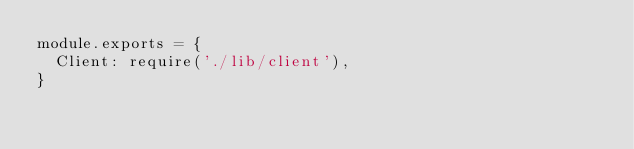<code> <loc_0><loc_0><loc_500><loc_500><_JavaScript_>module.exports = {
  Client: require('./lib/client'),
}
</code> 